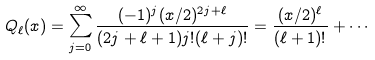Convert formula to latex. <formula><loc_0><loc_0><loc_500><loc_500>Q _ { \ell } ( x ) = \sum _ { j = 0 } ^ { \infty } \frac { ( - 1 ) ^ { j } ( x / 2 ) ^ { 2 j + \ell } } { ( 2 j + \ell + 1 ) j ! ( \ell + j ) ! } = \frac { ( x / 2 ) ^ { \ell } } { ( \ell + 1 ) ! } + \cdots</formula> 